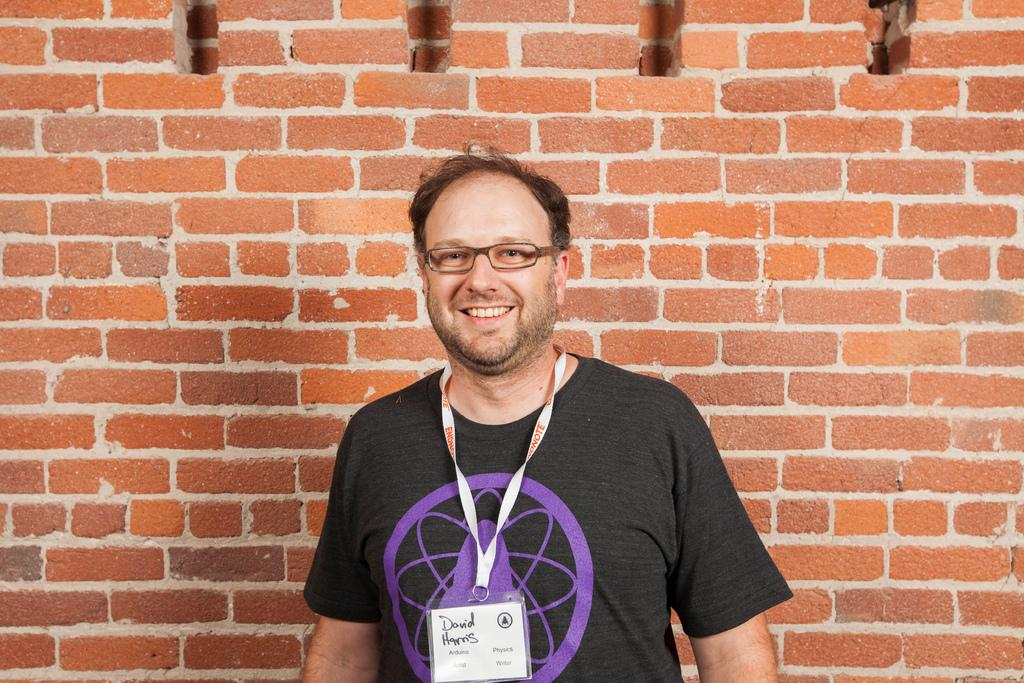What is the main subject of the image? There is a person in the image. What is the person doing in the image? The person is standing and smiling. What can be seen in the background of the image? There is a wall in the image. What is the appearance of the wall? The wall has red bricks. What type of veil is the person wearing in the image? There is no veil present in the image; the person is not wearing any head covering. What is the price of the wall in the image? The image does not provide information about the price of the wall, as it is a photograph and not a sales advertisement. 